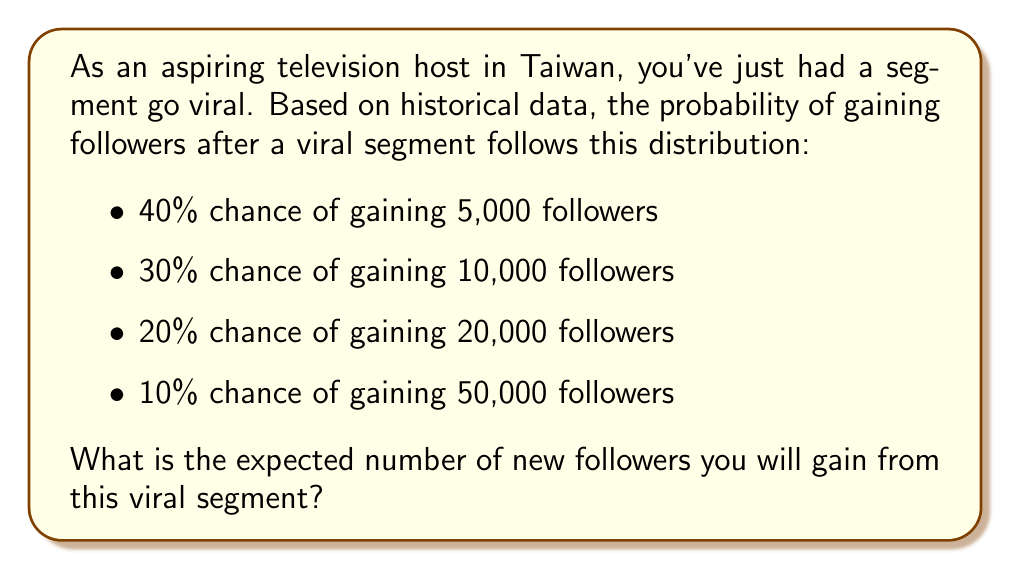Teach me how to tackle this problem. To calculate the expected value, we need to multiply each possible outcome by its probability and then sum these products. Let's break it down step-by-step:

1) First, let's identify our outcomes and their probabilities:
   - 5,000 followers with 40% probability
   - 10,000 followers with 30% probability
   - 20,000 followers with 20% probability
   - 50,000 followers with 10% probability

2) Now, let's calculate the contribution of each outcome to the expected value:
   - 5,000 * 0.40 = 2,000
   - 10,000 * 0.30 = 3,000
   - 20,000 * 0.20 = 4,000
   - 50,000 * 0.10 = 5,000

3) The expected value is the sum of these contributions:

   $$ E = (5,000 \cdot 0.40) + (10,000 \cdot 0.30) + (20,000 \cdot 0.20) + (50,000 \cdot 0.10) $$
   $$ E = 2,000 + 3,000 + 4,000 + 5,000 $$
   $$ E = 14,000 $$

Therefore, the expected number of new followers you will gain from this viral segment is 14,000.
Answer: 14,000 followers 